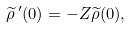Convert formula to latex. <formula><loc_0><loc_0><loc_500><loc_500>\widetilde { \rho } \, ^ { \prime } ( 0 ) = - Z \widetilde { \rho } ( 0 ) ,</formula> 